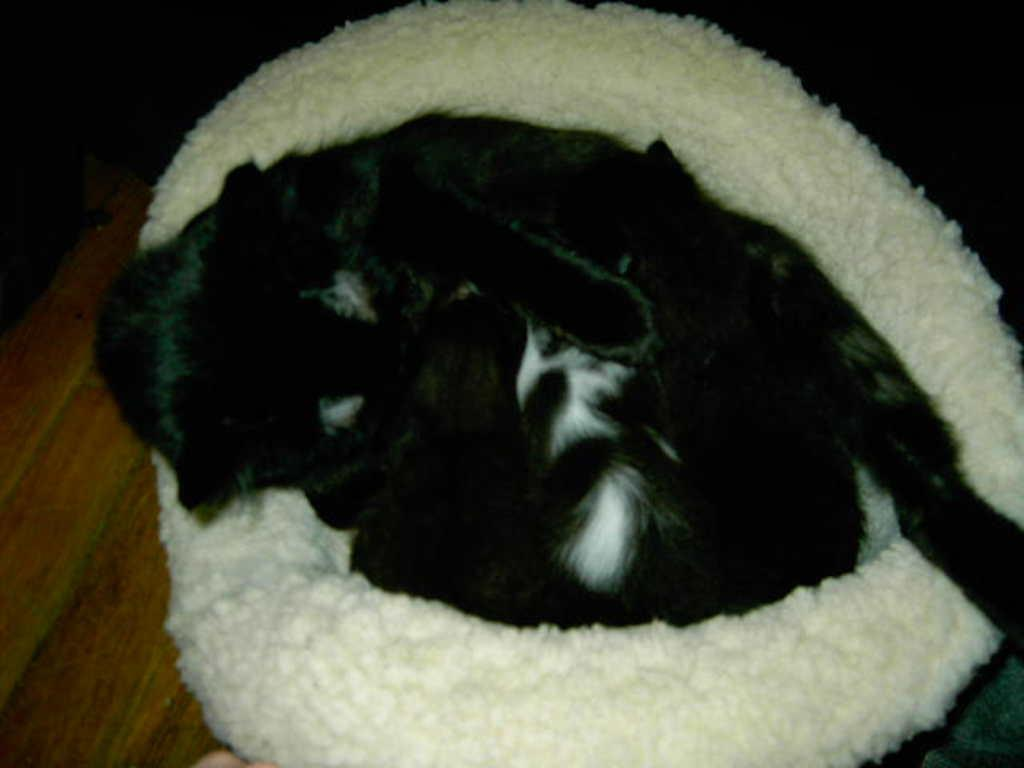What is the color of the object in the image? The object in the image is white-colored. What is on top of the white-colored object? There is a black-colored animal on the white-colored object. Can you tell me how many snakes are playing chess on the white-colored thing in the image? There are no snakes or chessboards present in the image; it features a white-colored object with a black-colored animal on top. 